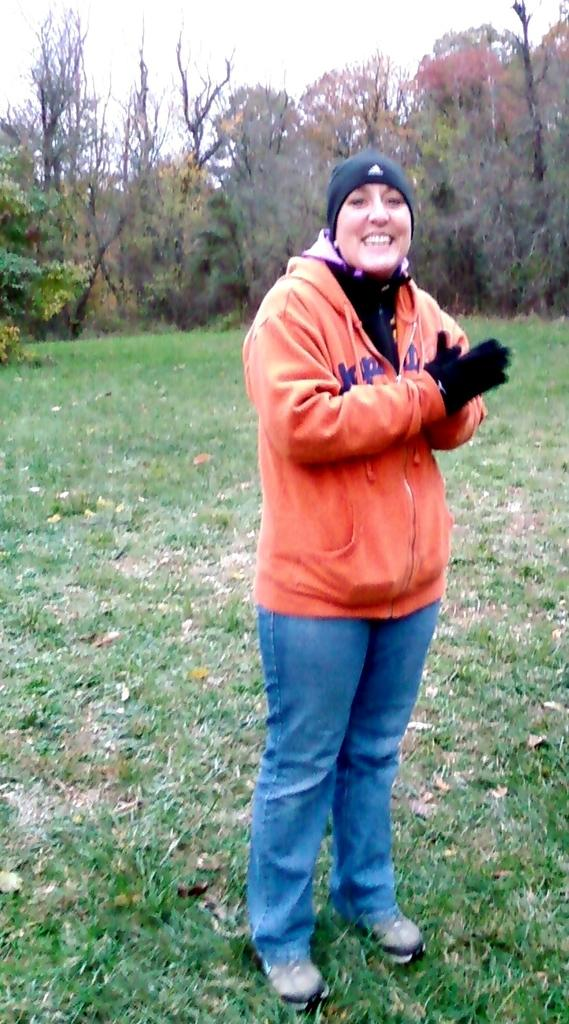What is the main subject of the image? There is a person in the image. What is the person's position in the image? The person is on the ground. What type of vegetation can be seen in the image? There is grass, plants, and trees in the image. What part of the natural environment is visible in the image? The sky is visible in the image. What type of nest can be seen in the image? There is no nest present in the image. How does the person in the image feel? The image does not convey the person's emotions or feelings. 